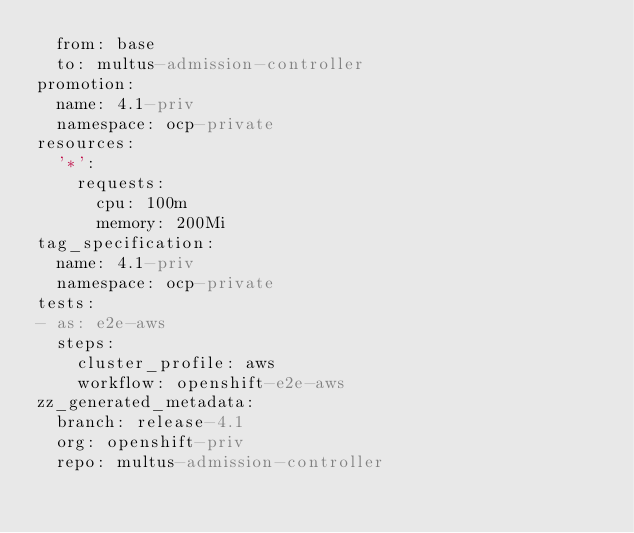Convert code to text. <code><loc_0><loc_0><loc_500><loc_500><_YAML_>  from: base
  to: multus-admission-controller
promotion:
  name: 4.1-priv
  namespace: ocp-private
resources:
  '*':
    requests:
      cpu: 100m
      memory: 200Mi
tag_specification:
  name: 4.1-priv
  namespace: ocp-private
tests:
- as: e2e-aws
  steps:
    cluster_profile: aws
    workflow: openshift-e2e-aws
zz_generated_metadata:
  branch: release-4.1
  org: openshift-priv
  repo: multus-admission-controller
</code> 